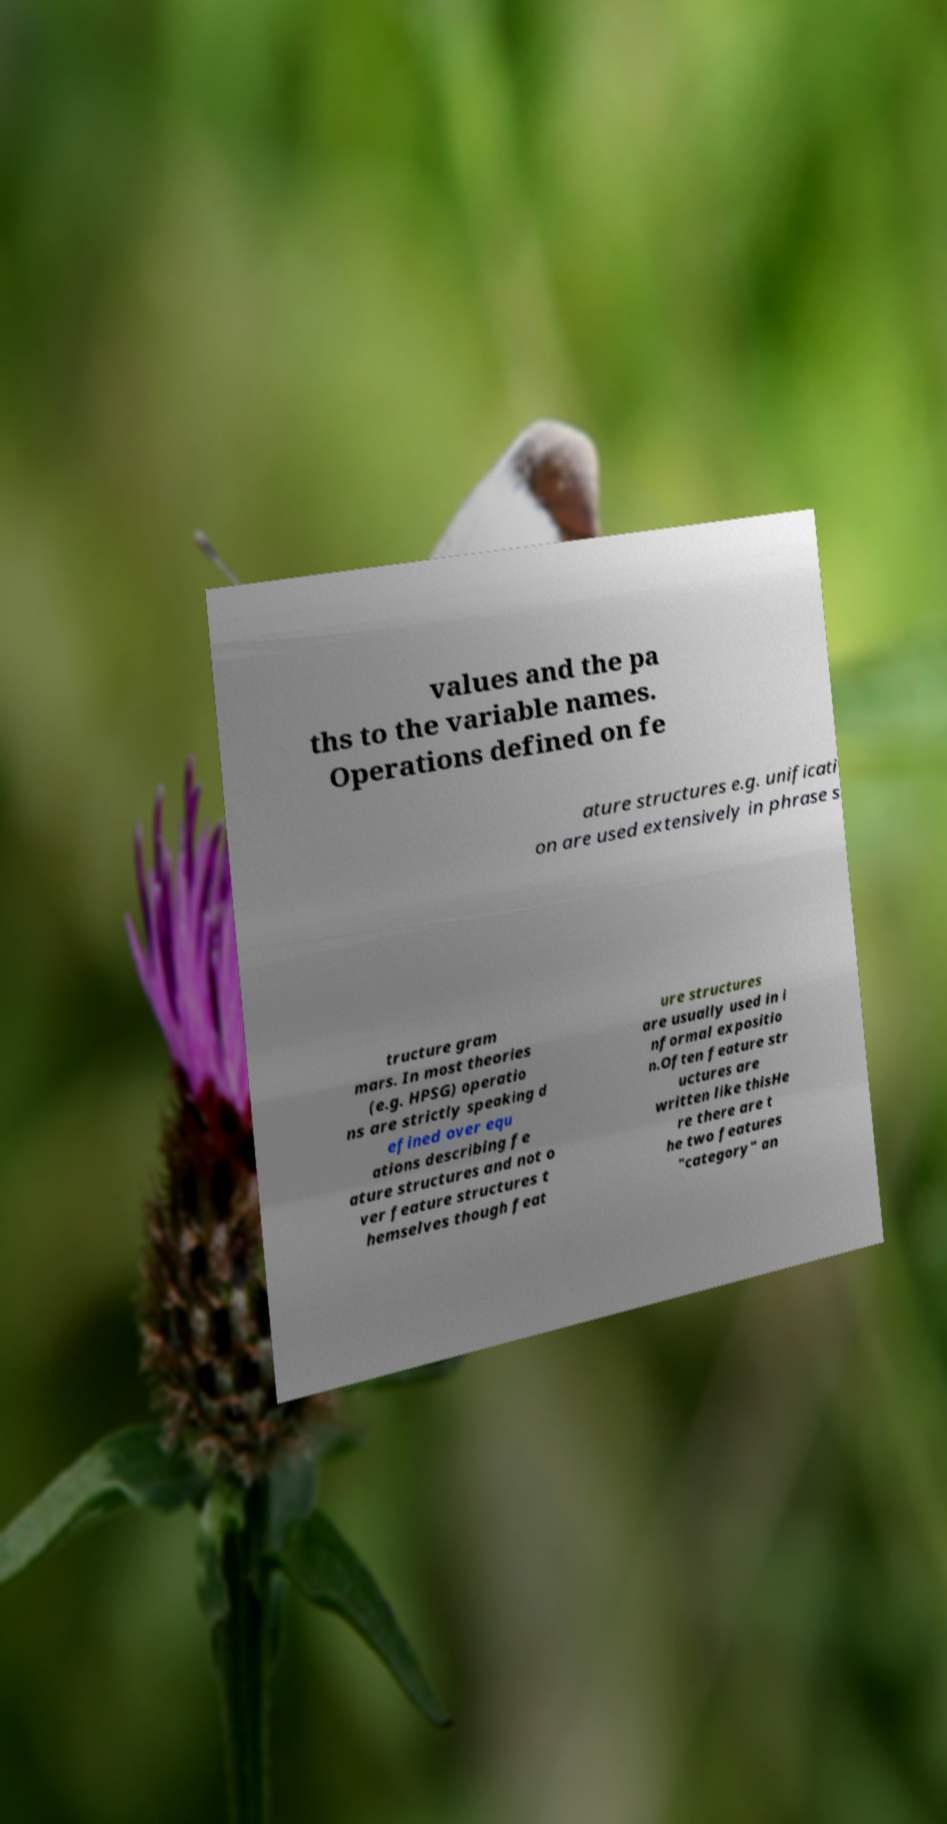Could you assist in decoding the text presented in this image and type it out clearly? values and the pa ths to the variable names. Operations defined on fe ature structures e.g. unificati on are used extensively in phrase s tructure gram mars. In most theories (e.g. HPSG) operatio ns are strictly speaking d efined over equ ations describing fe ature structures and not o ver feature structures t hemselves though feat ure structures are usually used in i nformal expositio n.Often feature str uctures are written like thisHe re there are t he two features "category" an 